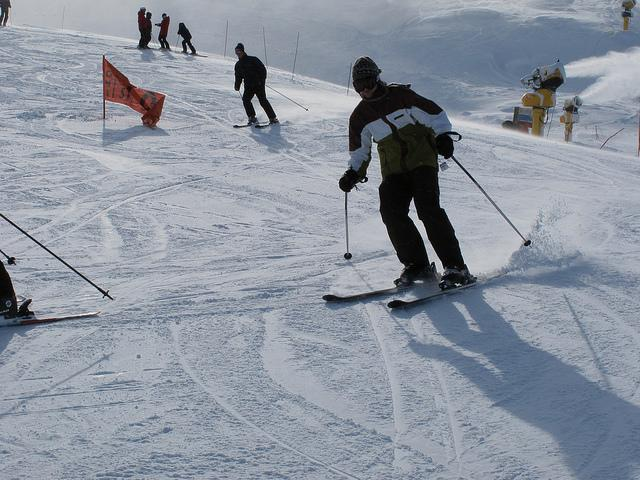What is this activity for? skiing 